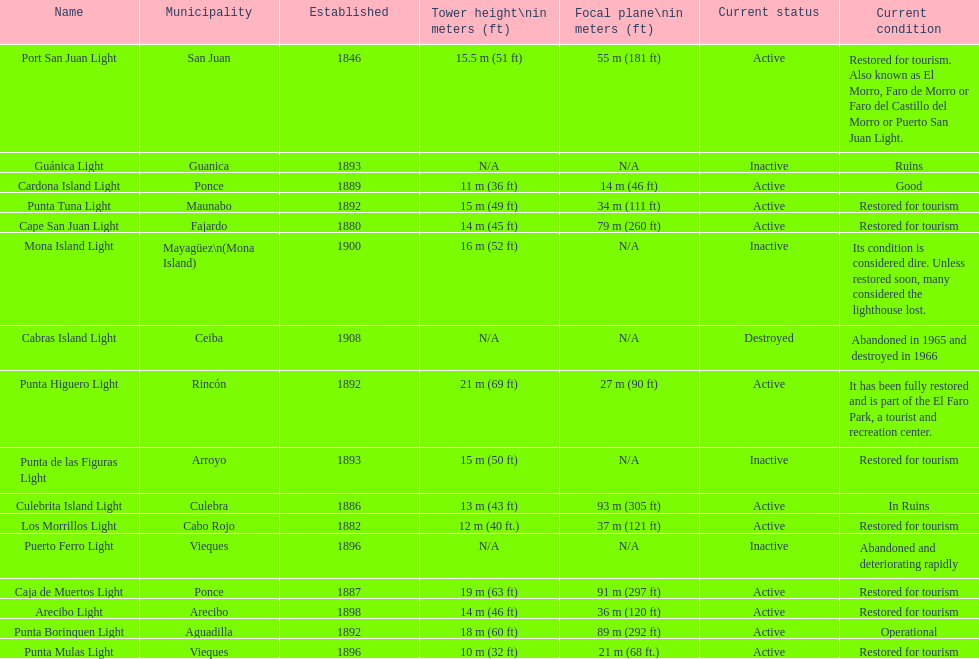Names of municipalities established before 1880 San Juan. 